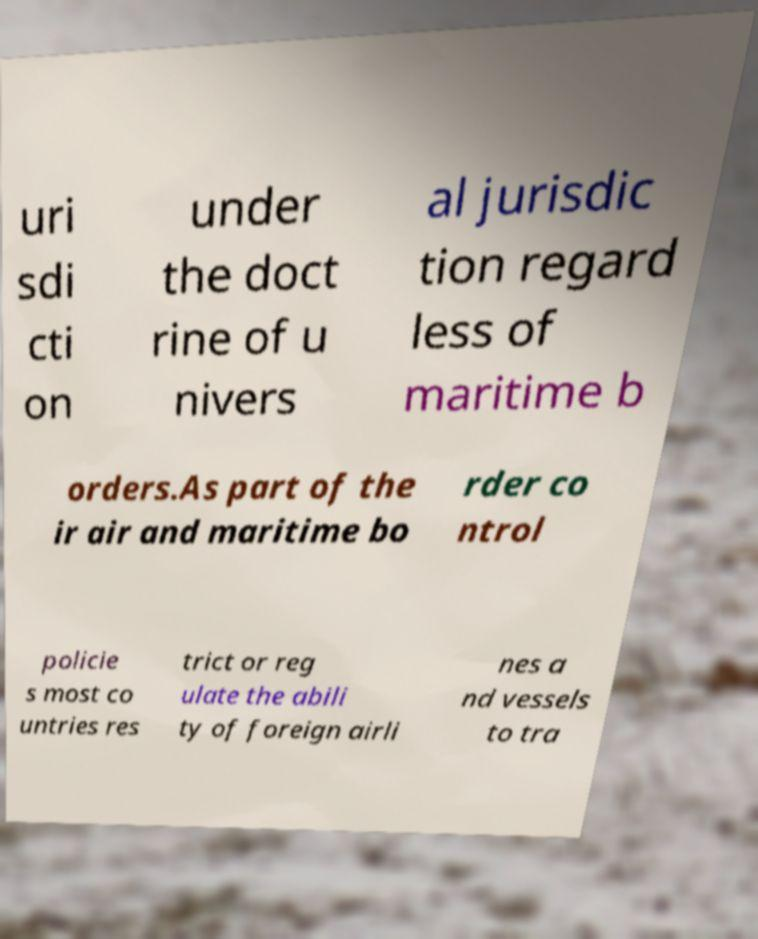Please read and relay the text visible in this image. What does it say? uri sdi cti on under the doct rine of u nivers al jurisdic tion regard less of maritime b orders.As part of the ir air and maritime bo rder co ntrol policie s most co untries res trict or reg ulate the abili ty of foreign airli nes a nd vessels to tra 